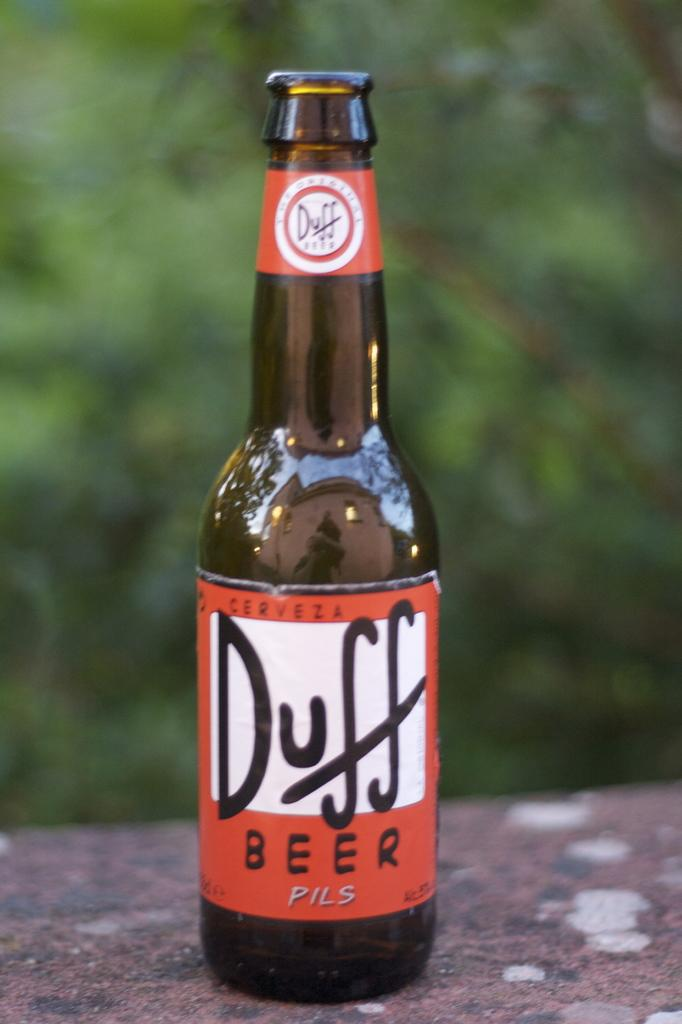<image>
Present a compact description of the photo's key features. A brown bottle of beer is labeled Duff. 